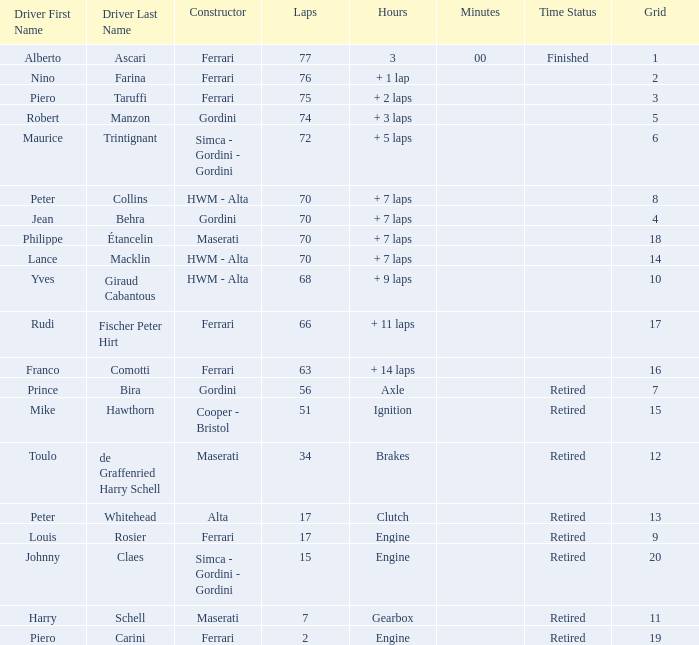How many grids for peter collins? 1.0. 